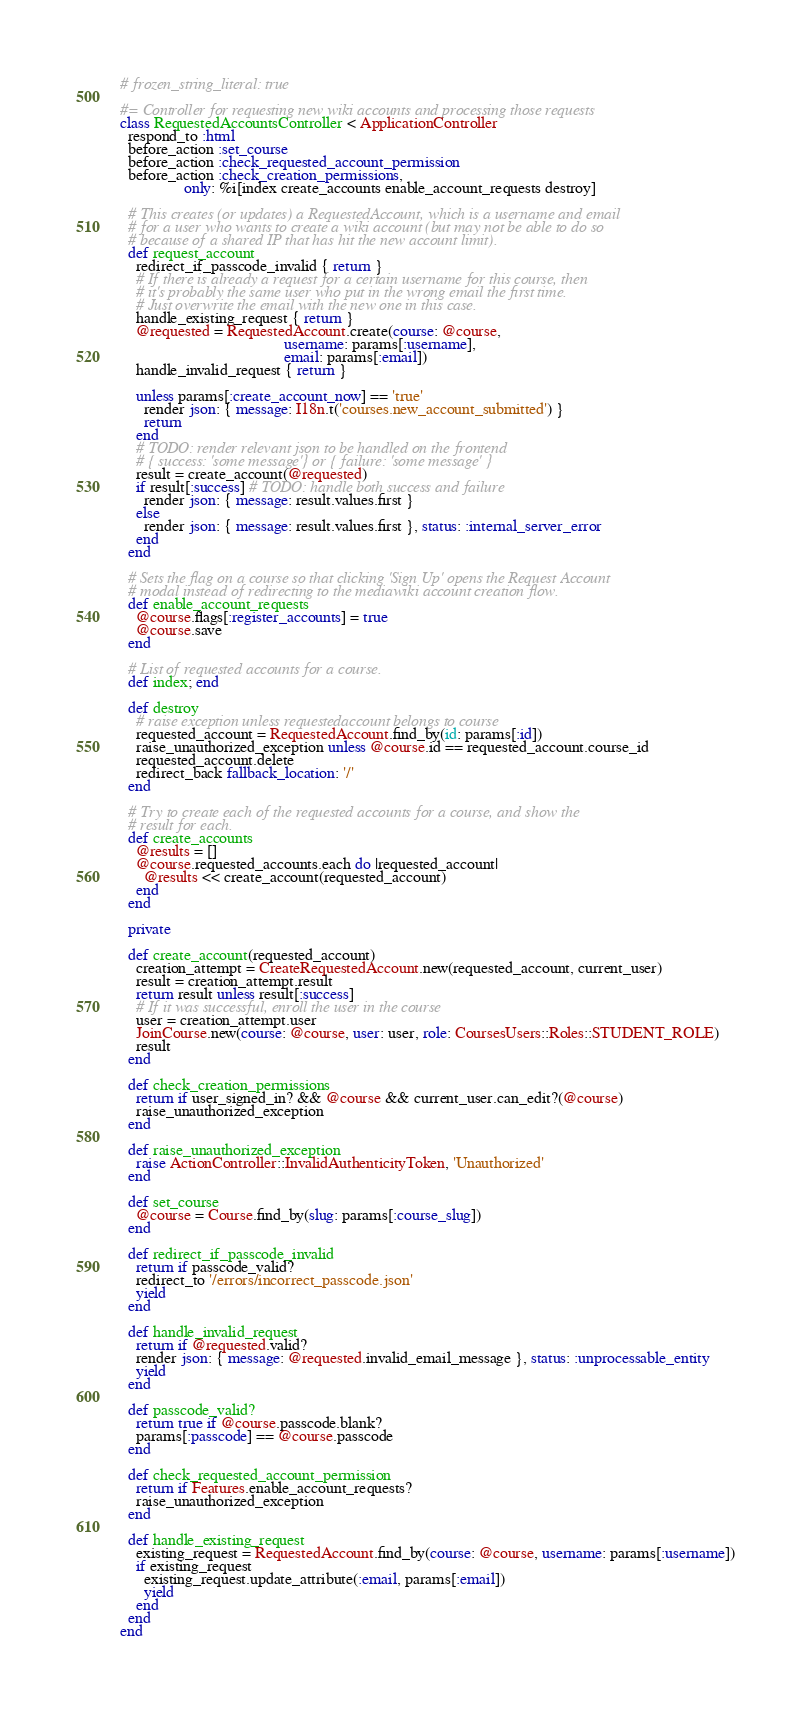<code> <loc_0><loc_0><loc_500><loc_500><_Ruby_># frozen_string_literal: true

#= Controller for requesting new wiki accounts and processing those requests
class RequestedAccountsController < ApplicationController
  respond_to :html
  before_action :set_course
  before_action :check_requested_account_permission
  before_action :check_creation_permissions,
                only: %i[index create_accounts enable_account_requests destroy]

  # This creates (or updates) a RequestedAccount, which is a username and email
  # for a user who wants to create a wiki account (but may not be able to do so
  # because of a shared IP that has hit the new account limit).
  def request_account
    redirect_if_passcode_invalid { return }
    # If there is already a request for a certain username for this course, then
    # it's probably the same user who put in the wrong email the first time.
    # Just overwrite the email with the new one in this case.
    handle_existing_request { return }
    @requested = RequestedAccount.create(course: @course,
                                         username: params[:username],
                                         email: params[:email])
    handle_invalid_request { return }

    unless params[:create_account_now] == 'true'
      render json: { message: I18n.t('courses.new_account_submitted') }
      return
    end
    # TODO: render relevant json to be handled on the frontend
    # { success: 'some message'} or { failure: 'some message' }
    result = create_account(@requested)
    if result[:success] # TODO: handle both success and failure
      render json: { message: result.values.first }
    else
      render json: { message: result.values.first }, status: :internal_server_error
    end
  end

  # Sets the flag on a course so that clicking 'Sign Up' opens the Request Account
  # modal instead of redirecting to the mediawiki account creation flow.
  def enable_account_requests
    @course.flags[:register_accounts] = true
    @course.save
  end

  # List of requested accounts for a course.
  def index; end

  def destroy
    # raise exception unless requestedaccount belongs to course
    requested_account = RequestedAccount.find_by(id: params[:id])
    raise_unauthorized_exception unless @course.id == requested_account.course_id
    requested_account.delete
    redirect_back fallback_location: '/'
  end

  # Try to create each of the requested accounts for a course, and show the
  # result for each.
  def create_accounts
    @results = []
    @course.requested_accounts.each do |requested_account|
      @results << create_account(requested_account)
    end
  end

  private

  def create_account(requested_account)
    creation_attempt = CreateRequestedAccount.new(requested_account, current_user)
    result = creation_attempt.result
    return result unless result[:success]
    # If it was successful, enroll the user in the course
    user = creation_attempt.user
    JoinCourse.new(course: @course, user: user, role: CoursesUsers::Roles::STUDENT_ROLE)
    result
  end

  def check_creation_permissions
    return if user_signed_in? && @course && current_user.can_edit?(@course)
    raise_unauthorized_exception
  end

  def raise_unauthorized_exception
    raise ActionController::InvalidAuthenticityToken, 'Unauthorized'
  end

  def set_course
    @course = Course.find_by(slug: params[:course_slug])
  end

  def redirect_if_passcode_invalid
    return if passcode_valid?
    redirect_to '/errors/incorrect_passcode.json'
    yield
  end

  def handle_invalid_request
    return if @requested.valid?
    render json: { message: @requested.invalid_email_message }, status: :unprocessable_entity
    yield
  end

  def passcode_valid?
    return true if @course.passcode.blank?
    params[:passcode] == @course.passcode
  end

  def check_requested_account_permission
    return if Features.enable_account_requests?
    raise_unauthorized_exception
  end

  def handle_existing_request
    existing_request = RequestedAccount.find_by(course: @course, username: params[:username])
    if existing_request
      existing_request.update_attribute(:email, params[:email])
      yield
    end
  end
end
</code> 